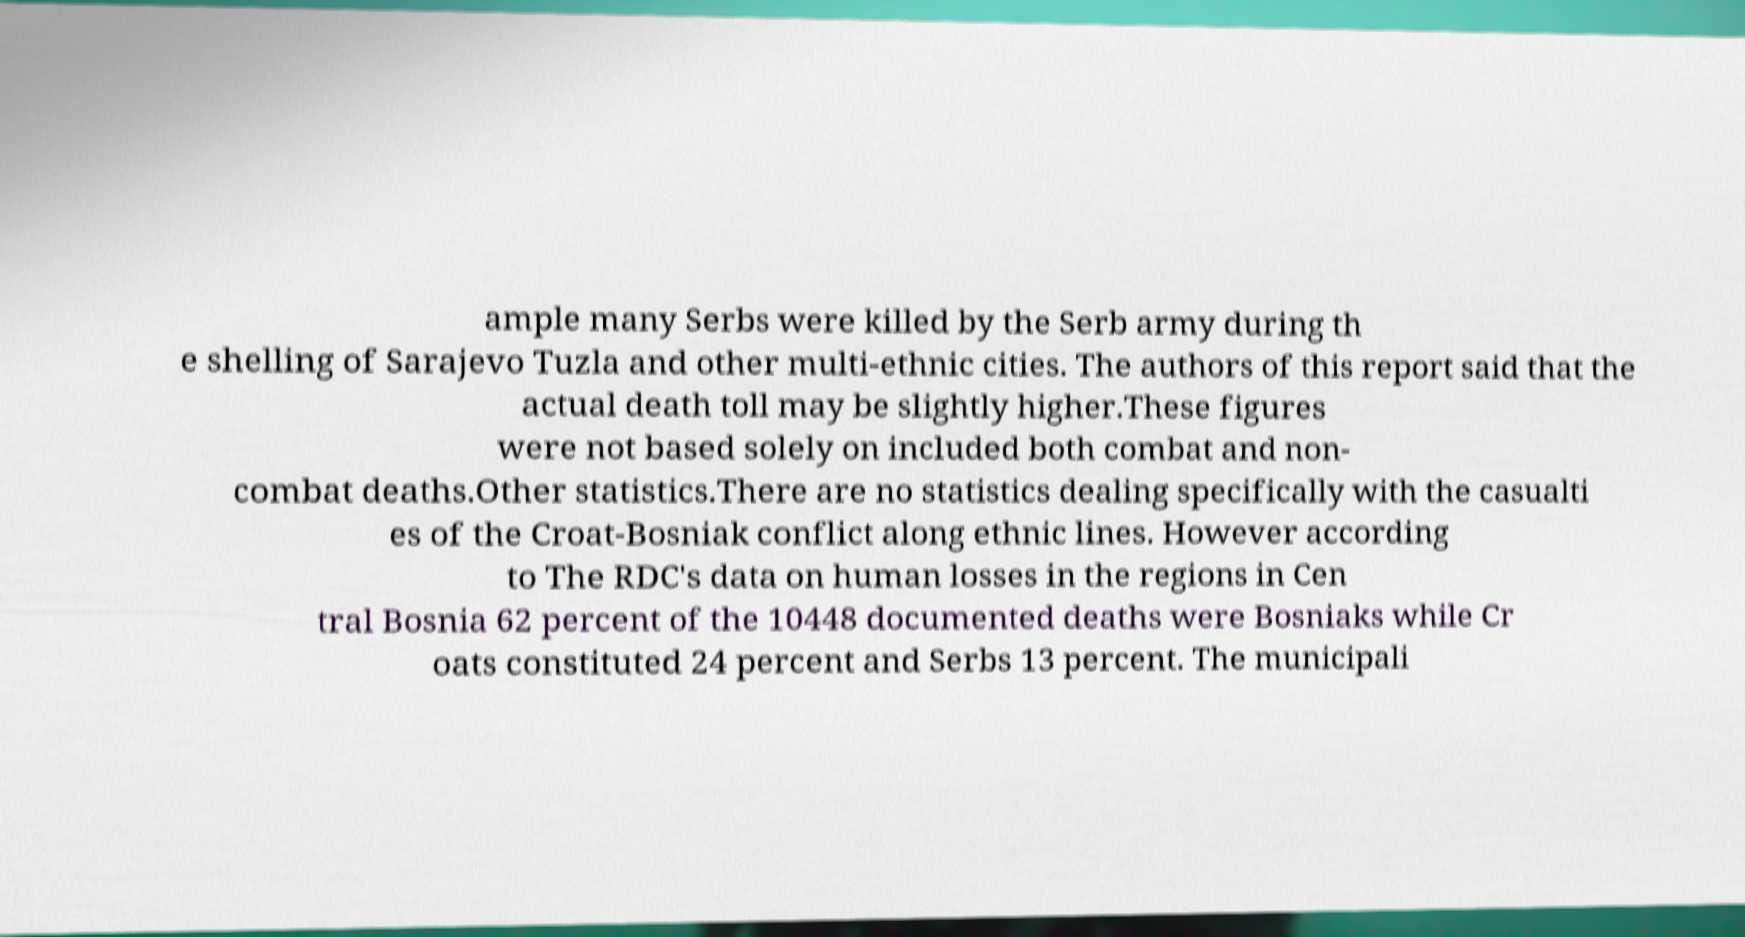For documentation purposes, I need the text within this image transcribed. Could you provide that? ample many Serbs were killed by the Serb army during th e shelling of Sarajevo Tuzla and other multi-ethnic cities. The authors of this report said that the actual death toll may be slightly higher.These figures were not based solely on included both combat and non- combat deaths.Other statistics.There are no statistics dealing specifically with the casualti es of the Croat-Bosniak conflict along ethnic lines. However according to The RDC's data on human losses in the regions in Cen tral Bosnia 62 percent of the 10448 documented deaths were Bosniaks while Cr oats constituted 24 percent and Serbs 13 percent. The municipali 